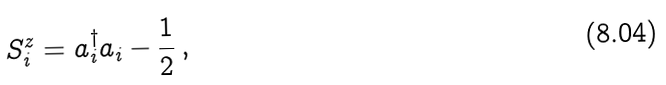Convert formula to latex. <formula><loc_0><loc_0><loc_500><loc_500>S _ { i } ^ { z } = a _ { i } ^ { \dag } a _ { i } - \frac { 1 } { 2 } \, ,</formula> 